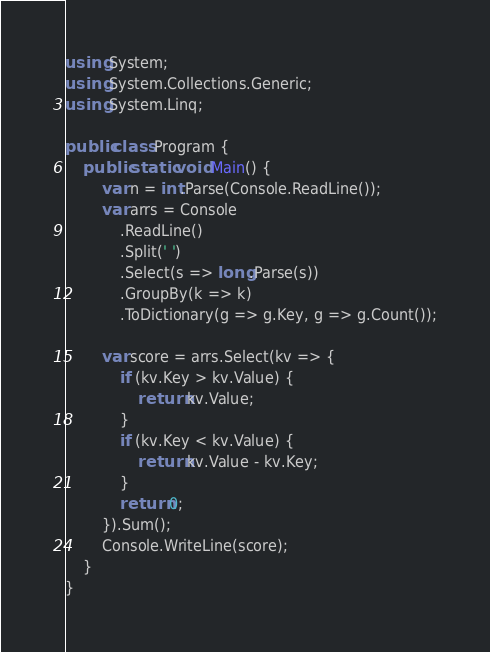<code> <loc_0><loc_0><loc_500><loc_500><_C#_>using System;
using System.Collections.Generic;
using System.Linq;

public class Program {
    public static void Main() {
        var n = int.Parse(Console.ReadLine());
        var arrs = Console
            .ReadLine()
            .Split(' ')
            .Select(s => long.Parse(s))
            .GroupBy(k => k)
            .ToDictionary(g => g.Key, g => g.Count());

        var score = arrs.Select(kv => {
            if (kv.Key > kv.Value) {
                return kv.Value;
            }
            if (kv.Key < kv.Value) {
                return kv.Value - kv.Key;
            }
            return 0;
        }).Sum();
        Console.WriteLine(score);
    }
}
</code> 